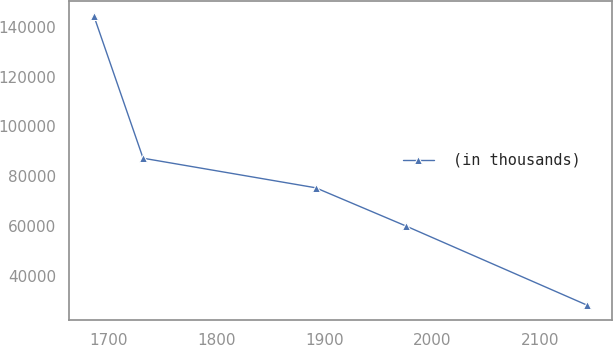<chart> <loc_0><loc_0><loc_500><loc_500><line_chart><ecel><fcel>(in thousands)<nl><fcel>1686.38<fcel>144492<nl><fcel>1732.08<fcel>87182.3<nl><fcel>1892.01<fcel>75298.4<nl><fcel>1975.53<fcel>59956.4<nl><fcel>2143.33<fcel>28157.6<nl></chart> 